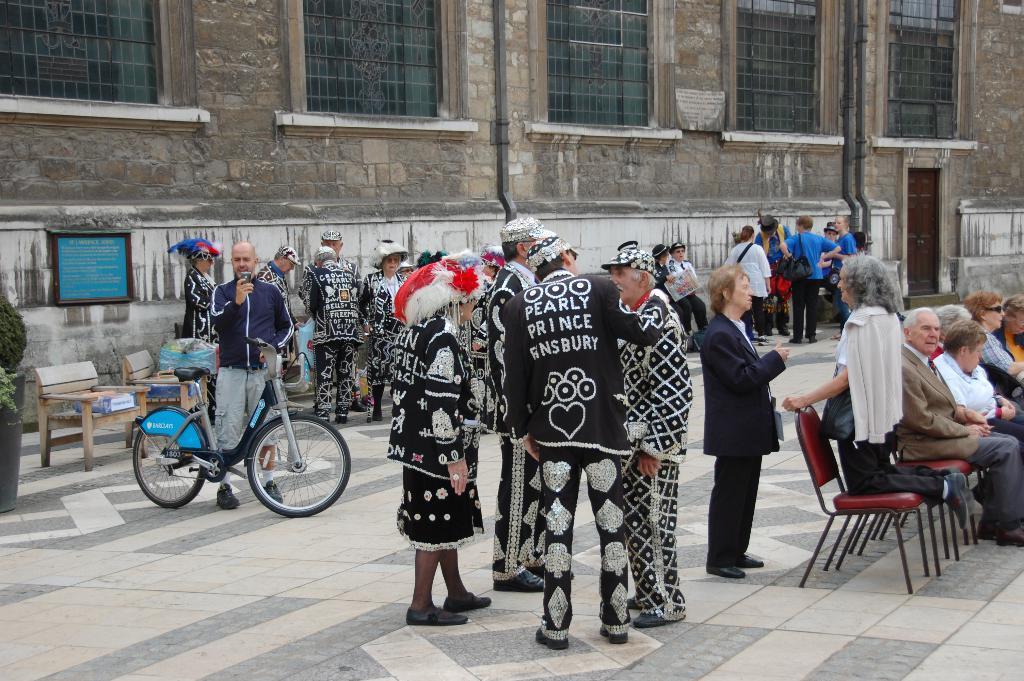Could you give a brief overview of what you see in this image? This picture are group of people standing and a man is standing with a bicycle and there is a building behind him 